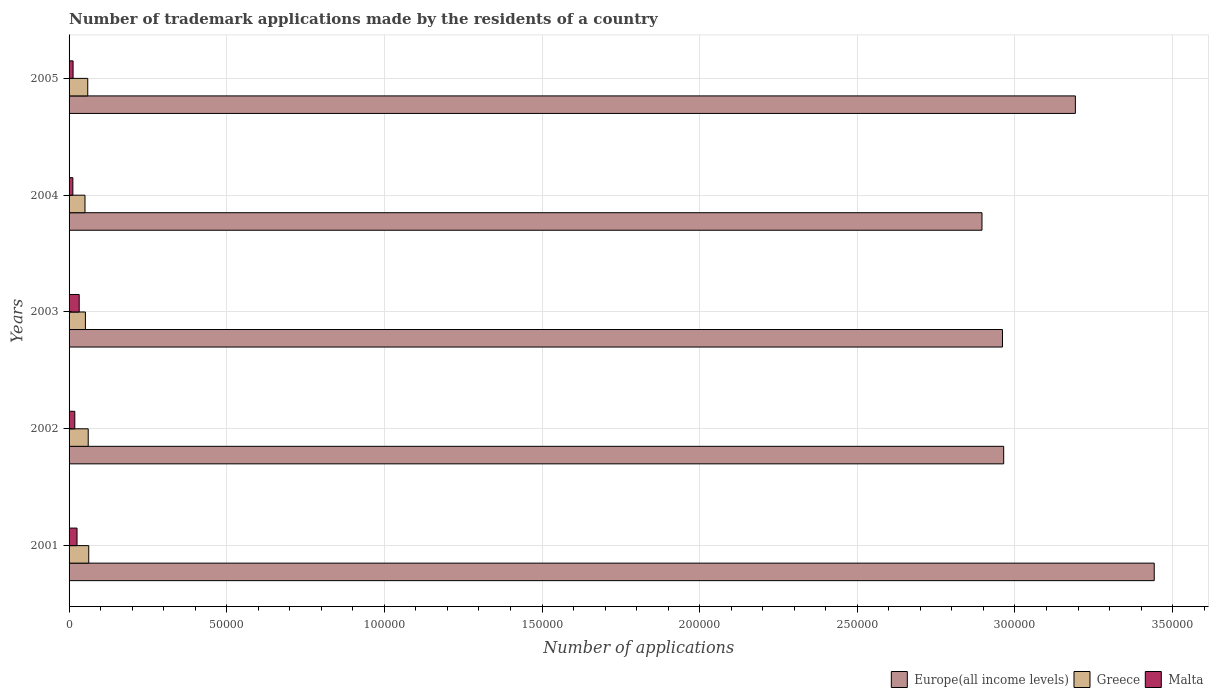How many groups of bars are there?
Ensure brevity in your answer.  5. Are the number of bars on each tick of the Y-axis equal?
Ensure brevity in your answer.  Yes. How many bars are there on the 1st tick from the top?
Offer a terse response. 3. What is the label of the 3rd group of bars from the top?
Give a very brief answer. 2003. What is the number of trademark applications made by the residents in Europe(all income levels) in 2005?
Offer a very short reply. 3.19e+05. Across all years, what is the maximum number of trademark applications made by the residents in Greece?
Offer a terse response. 6240. Across all years, what is the minimum number of trademark applications made by the residents in Malta?
Offer a terse response. 1200. In which year was the number of trademark applications made by the residents in Greece maximum?
Your response must be concise. 2001. In which year was the number of trademark applications made by the residents in Malta minimum?
Make the answer very short. 2004. What is the total number of trademark applications made by the residents in Greece in the graph?
Make the answer very short. 2.85e+04. What is the difference between the number of trademark applications made by the residents in Europe(all income levels) in 2003 and that in 2004?
Keep it short and to the point. 6506. What is the difference between the number of trademark applications made by the residents in Greece in 2003 and the number of trademark applications made by the residents in Malta in 2002?
Provide a succinct answer. 3365. What is the average number of trademark applications made by the residents in Malta per year?
Provide a short and direct response. 2004.4. In the year 2005, what is the difference between the number of trademark applications made by the residents in Europe(all income levels) and number of trademark applications made by the residents in Malta?
Make the answer very short. 3.18e+05. What is the ratio of the number of trademark applications made by the residents in Europe(all income levels) in 2003 to that in 2004?
Make the answer very short. 1.02. Is the difference between the number of trademark applications made by the residents in Europe(all income levels) in 2002 and 2004 greater than the difference between the number of trademark applications made by the residents in Malta in 2002 and 2004?
Ensure brevity in your answer.  Yes. What is the difference between the highest and the second highest number of trademark applications made by the residents in Greece?
Ensure brevity in your answer.  165. What is the difference between the highest and the lowest number of trademark applications made by the residents in Malta?
Your answer should be very brief. 2011. What does the 1st bar from the top in 2002 represents?
Keep it short and to the point. Malta. What does the 2nd bar from the bottom in 2005 represents?
Provide a short and direct response. Greece. Is it the case that in every year, the sum of the number of trademark applications made by the residents in Europe(all income levels) and number of trademark applications made by the residents in Greece is greater than the number of trademark applications made by the residents in Malta?
Your answer should be compact. Yes. Does the graph contain any zero values?
Offer a terse response. No. Does the graph contain grids?
Provide a succinct answer. Yes. How are the legend labels stacked?
Your answer should be very brief. Horizontal. What is the title of the graph?
Offer a terse response. Number of trademark applications made by the residents of a country. Does "Romania" appear as one of the legend labels in the graph?
Provide a succinct answer. No. What is the label or title of the X-axis?
Offer a terse response. Number of applications. What is the Number of applications of Europe(all income levels) in 2001?
Provide a short and direct response. 3.44e+05. What is the Number of applications of Greece in 2001?
Provide a succinct answer. 6240. What is the Number of applications in Malta in 2001?
Offer a very short reply. 2523. What is the Number of applications in Europe(all income levels) in 2002?
Offer a terse response. 2.96e+05. What is the Number of applications in Greece in 2002?
Offer a terse response. 6075. What is the Number of applications in Malta in 2002?
Ensure brevity in your answer.  1817. What is the Number of applications of Europe(all income levels) in 2003?
Give a very brief answer. 2.96e+05. What is the Number of applications in Greece in 2003?
Provide a short and direct response. 5182. What is the Number of applications of Malta in 2003?
Your answer should be compact. 3211. What is the Number of applications of Europe(all income levels) in 2004?
Ensure brevity in your answer.  2.90e+05. What is the Number of applications in Greece in 2004?
Provide a short and direct response. 5045. What is the Number of applications of Malta in 2004?
Make the answer very short. 1200. What is the Number of applications in Europe(all income levels) in 2005?
Make the answer very short. 3.19e+05. What is the Number of applications of Greece in 2005?
Offer a very short reply. 5926. What is the Number of applications in Malta in 2005?
Offer a terse response. 1271. Across all years, what is the maximum Number of applications of Europe(all income levels)?
Your response must be concise. 3.44e+05. Across all years, what is the maximum Number of applications in Greece?
Offer a terse response. 6240. Across all years, what is the maximum Number of applications of Malta?
Your answer should be very brief. 3211. Across all years, what is the minimum Number of applications in Europe(all income levels)?
Offer a terse response. 2.90e+05. Across all years, what is the minimum Number of applications in Greece?
Provide a short and direct response. 5045. Across all years, what is the minimum Number of applications of Malta?
Offer a terse response. 1200. What is the total Number of applications in Europe(all income levels) in the graph?
Provide a short and direct response. 1.55e+06. What is the total Number of applications of Greece in the graph?
Keep it short and to the point. 2.85e+04. What is the total Number of applications of Malta in the graph?
Ensure brevity in your answer.  1.00e+04. What is the difference between the Number of applications of Europe(all income levels) in 2001 and that in 2002?
Your answer should be very brief. 4.77e+04. What is the difference between the Number of applications of Greece in 2001 and that in 2002?
Provide a short and direct response. 165. What is the difference between the Number of applications of Malta in 2001 and that in 2002?
Make the answer very short. 706. What is the difference between the Number of applications in Europe(all income levels) in 2001 and that in 2003?
Your response must be concise. 4.81e+04. What is the difference between the Number of applications in Greece in 2001 and that in 2003?
Give a very brief answer. 1058. What is the difference between the Number of applications in Malta in 2001 and that in 2003?
Your answer should be compact. -688. What is the difference between the Number of applications in Europe(all income levels) in 2001 and that in 2004?
Your response must be concise. 5.46e+04. What is the difference between the Number of applications in Greece in 2001 and that in 2004?
Ensure brevity in your answer.  1195. What is the difference between the Number of applications of Malta in 2001 and that in 2004?
Your answer should be very brief. 1323. What is the difference between the Number of applications in Europe(all income levels) in 2001 and that in 2005?
Make the answer very short. 2.50e+04. What is the difference between the Number of applications of Greece in 2001 and that in 2005?
Ensure brevity in your answer.  314. What is the difference between the Number of applications of Malta in 2001 and that in 2005?
Offer a terse response. 1252. What is the difference between the Number of applications of Europe(all income levels) in 2002 and that in 2003?
Offer a terse response. 381. What is the difference between the Number of applications in Greece in 2002 and that in 2003?
Offer a terse response. 893. What is the difference between the Number of applications in Malta in 2002 and that in 2003?
Offer a terse response. -1394. What is the difference between the Number of applications of Europe(all income levels) in 2002 and that in 2004?
Keep it short and to the point. 6887. What is the difference between the Number of applications of Greece in 2002 and that in 2004?
Your answer should be compact. 1030. What is the difference between the Number of applications of Malta in 2002 and that in 2004?
Ensure brevity in your answer.  617. What is the difference between the Number of applications in Europe(all income levels) in 2002 and that in 2005?
Your answer should be very brief. -2.27e+04. What is the difference between the Number of applications in Greece in 2002 and that in 2005?
Provide a short and direct response. 149. What is the difference between the Number of applications in Malta in 2002 and that in 2005?
Provide a short and direct response. 546. What is the difference between the Number of applications in Europe(all income levels) in 2003 and that in 2004?
Your response must be concise. 6506. What is the difference between the Number of applications of Greece in 2003 and that in 2004?
Give a very brief answer. 137. What is the difference between the Number of applications in Malta in 2003 and that in 2004?
Your response must be concise. 2011. What is the difference between the Number of applications of Europe(all income levels) in 2003 and that in 2005?
Make the answer very short. -2.31e+04. What is the difference between the Number of applications in Greece in 2003 and that in 2005?
Offer a very short reply. -744. What is the difference between the Number of applications in Malta in 2003 and that in 2005?
Your answer should be very brief. 1940. What is the difference between the Number of applications of Europe(all income levels) in 2004 and that in 2005?
Make the answer very short. -2.96e+04. What is the difference between the Number of applications in Greece in 2004 and that in 2005?
Make the answer very short. -881. What is the difference between the Number of applications in Malta in 2004 and that in 2005?
Ensure brevity in your answer.  -71. What is the difference between the Number of applications in Europe(all income levels) in 2001 and the Number of applications in Greece in 2002?
Provide a short and direct response. 3.38e+05. What is the difference between the Number of applications of Europe(all income levels) in 2001 and the Number of applications of Malta in 2002?
Provide a short and direct response. 3.42e+05. What is the difference between the Number of applications in Greece in 2001 and the Number of applications in Malta in 2002?
Your response must be concise. 4423. What is the difference between the Number of applications in Europe(all income levels) in 2001 and the Number of applications in Greece in 2003?
Your response must be concise. 3.39e+05. What is the difference between the Number of applications in Europe(all income levels) in 2001 and the Number of applications in Malta in 2003?
Offer a very short reply. 3.41e+05. What is the difference between the Number of applications of Greece in 2001 and the Number of applications of Malta in 2003?
Your answer should be very brief. 3029. What is the difference between the Number of applications in Europe(all income levels) in 2001 and the Number of applications in Greece in 2004?
Your response must be concise. 3.39e+05. What is the difference between the Number of applications of Europe(all income levels) in 2001 and the Number of applications of Malta in 2004?
Your answer should be very brief. 3.43e+05. What is the difference between the Number of applications in Greece in 2001 and the Number of applications in Malta in 2004?
Ensure brevity in your answer.  5040. What is the difference between the Number of applications of Europe(all income levels) in 2001 and the Number of applications of Greece in 2005?
Offer a very short reply. 3.38e+05. What is the difference between the Number of applications of Europe(all income levels) in 2001 and the Number of applications of Malta in 2005?
Provide a succinct answer. 3.43e+05. What is the difference between the Number of applications in Greece in 2001 and the Number of applications in Malta in 2005?
Make the answer very short. 4969. What is the difference between the Number of applications in Europe(all income levels) in 2002 and the Number of applications in Greece in 2003?
Your answer should be very brief. 2.91e+05. What is the difference between the Number of applications of Europe(all income levels) in 2002 and the Number of applications of Malta in 2003?
Ensure brevity in your answer.  2.93e+05. What is the difference between the Number of applications in Greece in 2002 and the Number of applications in Malta in 2003?
Ensure brevity in your answer.  2864. What is the difference between the Number of applications of Europe(all income levels) in 2002 and the Number of applications of Greece in 2004?
Your answer should be very brief. 2.91e+05. What is the difference between the Number of applications of Europe(all income levels) in 2002 and the Number of applications of Malta in 2004?
Provide a short and direct response. 2.95e+05. What is the difference between the Number of applications of Greece in 2002 and the Number of applications of Malta in 2004?
Provide a succinct answer. 4875. What is the difference between the Number of applications in Europe(all income levels) in 2002 and the Number of applications in Greece in 2005?
Ensure brevity in your answer.  2.90e+05. What is the difference between the Number of applications in Europe(all income levels) in 2002 and the Number of applications in Malta in 2005?
Your answer should be very brief. 2.95e+05. What is the difference between the Number of applications of Greece in 2002 and the Number of applications of Malta in 2005?
Provide a succinct answer. 4804. What is the difference between the Number of applications of Europe(all income levels) in 2003 and the Number of applications of Greece in 2004?
Provide a succinct answer. 2.91e+05. What is the difference between the Number of applications in Europe(all income levels) in 2003 and the Number of applications in Malta in 2004?
Provide a short and direct response. 2.95e+05. What is the difference between the Number of applications in Greece in 2003 and the Number of applications in Malta in 2004?
Provide a succinct answer. 3982. What is the difference between the Number of applications of Europe(all income levels) in 2003 and the Number of applications of Greece in 2005?
Ensure brevity in your answer.  2.90e+05. What is the difference between the Number of applications of Europe(all income levels) in 2003 and the Number of applications of Malta in 2005?
Your answer should be compact. 2.95e+05. What is the difference between the Number of applications in Greece in 2003 and the Number of applications in Malta in 2005?
Your answer should be very brief. 3911. What is the difference between the Number of applications of Europe(all income levels) in 2004 and the Number of applications of Greece in 2005?
Provide a short and direct response. 2.84e+05. What is the difference between the Number of applications of Europe(all income levels) in 2004 and the Number of applications of Malta in 2005?
Keep it short and to the point. 2.88e+05. What is the difference between the Number of applications in Greece in 2004 and the Number of applications in Malta in 2005?
Your answer should be compact. 3774. What is the average Number of applications of Europe(all income levels) per year?
Offer a terse response. 3.09e+05. What is the average Number of applications of Greece per year?
Make the answer very short. 5693.6. What is the average Number of applications of Malta per year?
Your answer should be compact. 2004.4. In the year 2001, what is the difference between the Number of applications of Europe(all income levels) and Number of applications of Greece?
Provide a succinct answer. 3.38e+05. In the year 2001, what is the difference between the Number of applications of Europe(all income levels) and Number of applications of Malta?
Offer a terse response. 3.42e+05. In the year 2001, what is the difference between the Number of applications of Greece and Number of applications of Malta?
Your response must be concise. 3717. In the year 2002, what is the difference between the Number of applications of Europe(all income levels) and Number of applications of Greece?
Your answer should be very brief. 2.90e+05. In the year 2002, what is the difference between the Number of applications in Europe(all income levels) and Number of applications in Malta?
Provide a short and direct response. 2.95e+05. In the year 2002, what is the difference between the Number of applications of Greece and Number of applications of Malta?
Ensure brevity in your answer.  4258. In the year 2003, what is the difference between the Number of applications of Europe(all income levels) and Number of applications of Greece?
Give a very brief answer. 2.91e+05. In the year 2003, what is the difference between the Number of applications of Europe(all income levels) and Number of applications of Malta?
Your answer should be compact. 2.93e+05. In the year 2003, what is the difference between the Number of applications of Greece and Number of applications of Malta?
Your answer should be very brief. 1971. In the year 2004, what is the difference between the Number of applications of Europe(all income levels) and Number of applications of Greece?
Offer a terse response. 2.84e+05. In the year 2004, what is the difference between the Number of applications of Europe(all income levels) and Number of applications of Malta?
Offer a terse response. 2.88e+05. In the year 2004, what is the difference between the Number of applications in Greece and Number of applications in Malta?
Make the answer very short. 3845. In the year 2005, what is the difference between the Number of applications of Europe(all income levels) and Number of applications of Greece?
Make the answer very short. 3.13e+05. In the year 2005, what is the difference between the Number of applications in Europe(all income levels) and Number of applications in Malta?
Your answer should be compact. 3.18e+05. In the year 2005, what is the difference between the Number of applications in Greece and Number of applications in Malta?
Provide a succinct answer. 4655. What is the ratio of the Number of applications of Europe(all income levels) in 2001 to that in 2002?
Make the answer very short. 1.16. What is the ratio of the Number of applications of Greece in 2001 to that in 2002?
Provide a short and direct response. 1.03. What is the ratio of the Number of applications in Malta in 2001 to that in 2002?
Ensure brevity in your answer.  1.39. What is the ratio of the Number of applications of Europe(all income levels) in 2001 to that in 2003?
Provide a short and direct response. 1.16. What is the ratio of the Number of applications of Greece in 2001 to that in 2003?
Your answer should be compact. 1.2. What is the ratio of the Number of applications of Malta in 2001 to that in 2003?
Offer a terse response. 0.79. What is the ratio of the Number of applications of Europe(all income levels) in 2001 to that in 2004?
Offer a terse response. 1.19. What is the ratio of the Number of applications of Greece in 2001 to that in 2004?
Keep it short and to the point. 1.24. What is the ratio of the Number of applications in Malta in 2001 to that in 2004?
Ensure brevity in your answer.  2.1. What is the ratio of the Number of applications of Europe(all income levels) in 2001 to that in 2005?
Offer a very short reply. 1.08. What is the ratio of the Number of applications of Greece in 2001 to that in 2005?
Offer a very short reply. 1.05. What is the ratio of the Number of applications of Malta in 2001 to that in 2005?
Your answer should be compact. 1.99. What is the ratio of the Number of applications in Europe(all income levels) in 2002 to that in 2003?
Your response must be concise. 1. What is the ratio of the Number of applications in Greece in 2002 to that in 2003?
Provide a short and direct response. 1.17. What is the ratio of the Number of applications of Malta in 2002 to that in 2003?
Give a very brief answer. 0.57. What is the ratio of the Number of applications of Europe(all income levels) in 2002 to that in 2004?
Keep it short and to the point. 1.02. What is the ratio of the Number of applications of Greece in 2002 to that in 2004?
Make the answer very short. 1.2. What is the ratio of the Number of applications in Malta in 2002 to that in 2004?
Make the answer very short. 1.51. What is the ratio of the Number of applications in Europe(all income levels) in 2002 to that in 2005?
Keep it short and to the point. 0.93. What is the ratio of the Number of applications in Greece in 2002 to that in 2005?
Provide a succinct answer. 1.03. What is the ratio of the Number of applications in Malta in 2002 to that in 2005?
Provide a short and direct response. 1.43. What is the ratio of the Number of applications in Europe(all income levels) in 2003 to that in 2004?
Keep it short and to the point. 1.02. What is the ratio of the Number of applications in Greece in 2003 to that in 2004?
Your answer should be very brief. 1.03. What is the ratio of the Number of applications in Malta in 2003 to that in 2004?
Your answer should be compact. 2.68. What is the ratio of the Number of applications of Europe(all income levels) in 2003 to that in 2005?
Offer a terse response. 0.93. What is the ratio of the Number of applications of Greece in 2003 to that in 2005?
Provide a short and direct response. 0.87. What is the ratio of the Number of applications in Malta in 2003 to that in 2005?
Your answer should be very brief. 2.53. What is the ratio of the Number of applications in Europe(all income levels) in 2004 to that in 2005?
Your response must be concise. 0.91. What is the ratio of the Number of applications in Greece in 2004 to that in 2005?
Your answer should be very brief. 0.85. What is the ratio of the Number of applications of Malta in 2004 to that in 2005?
Make the answer very short. 0.94. What is the difference between the highest and the second highest Number of applications in Europe(all income levels)?
Offer a terse response. 2.50e+04. What is the difference between the highest and the second highest Number of applications of Greece?
Offer a very short reply. 165. What is the difference between the highest and the second highest Number of applications in Malta?
Provide a short and direct response. 688. What is the difference between the highest and the lowest Number of applications in Europe(all income levels)?
Keep it short and to the point. 5.46e+04. What is the difference between the highest and the lowest Number of applications in Greece?
Offer a terse response. 1195. What is the difference between the highest and the lowest Number of applications in Malta?
Give a very brief answer. 2011. 